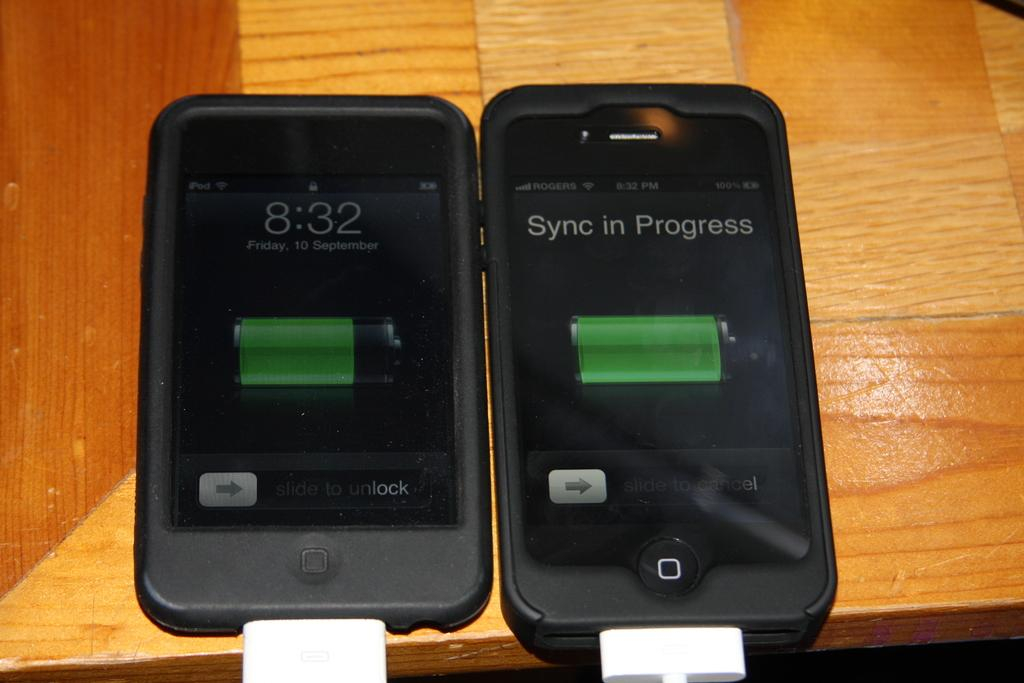<image>
Give a short and clear explanation of the subsequent image. Two phones are Sync in Progress at 8:32. 